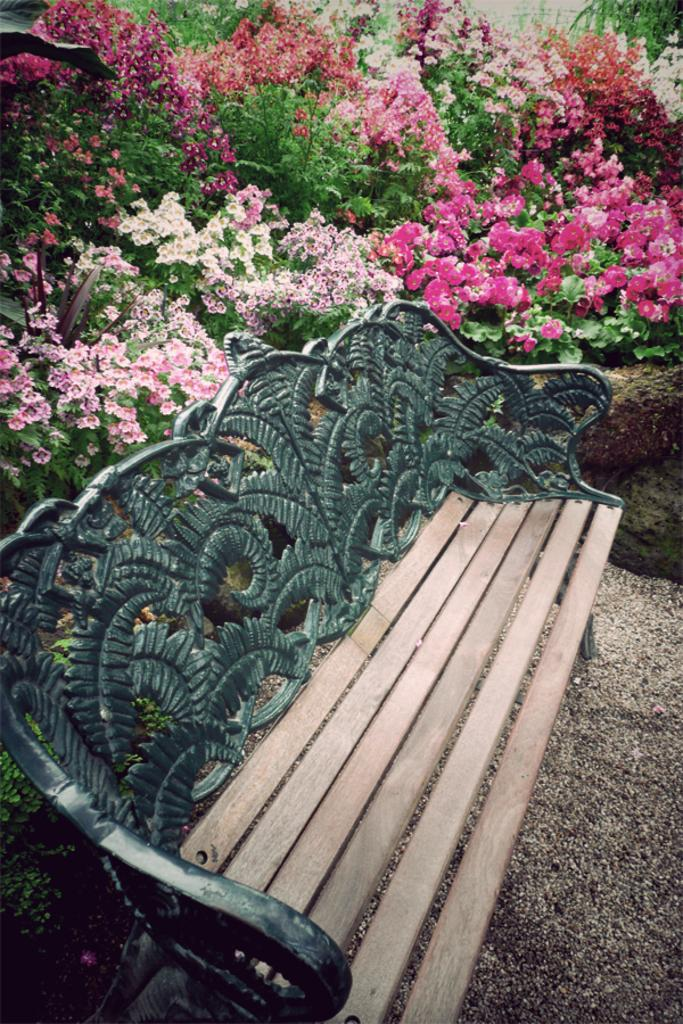What type of seating is visible in the image? There is a bench in the image. What can be seen behind the bench? There are different color flowers and plants behind the bench. What type of popcorn is being blown by the foot in the image? There is no popcorn or foot present in the image. 